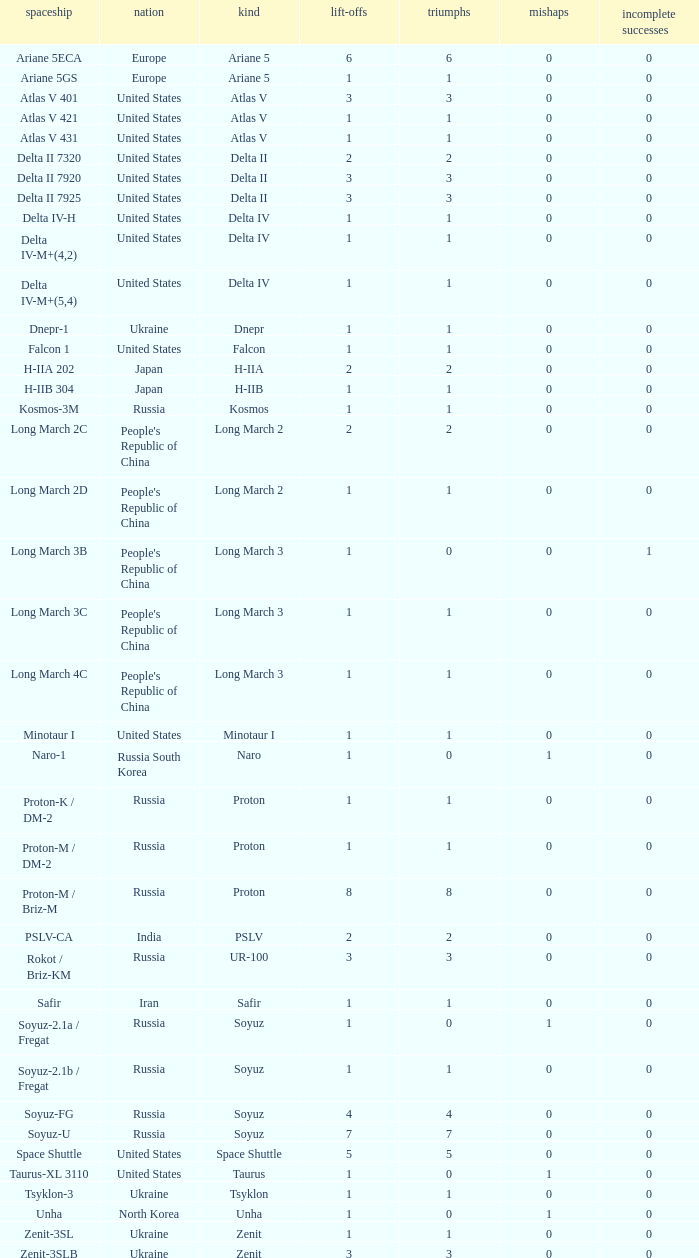What's the total failures among rockets that had more than 3 successes, type ariane 5 and more than 0 partial failures? 0.0. 